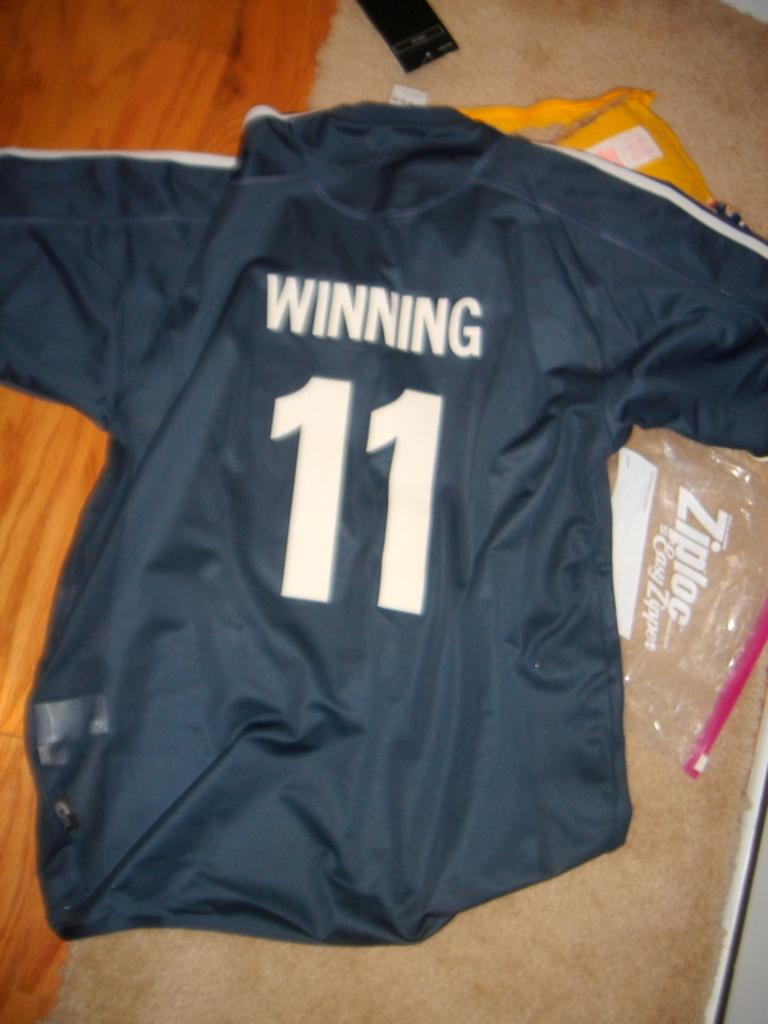<image>
Provide a brief description of the given image. A black jersey says Winning 11 on the back 